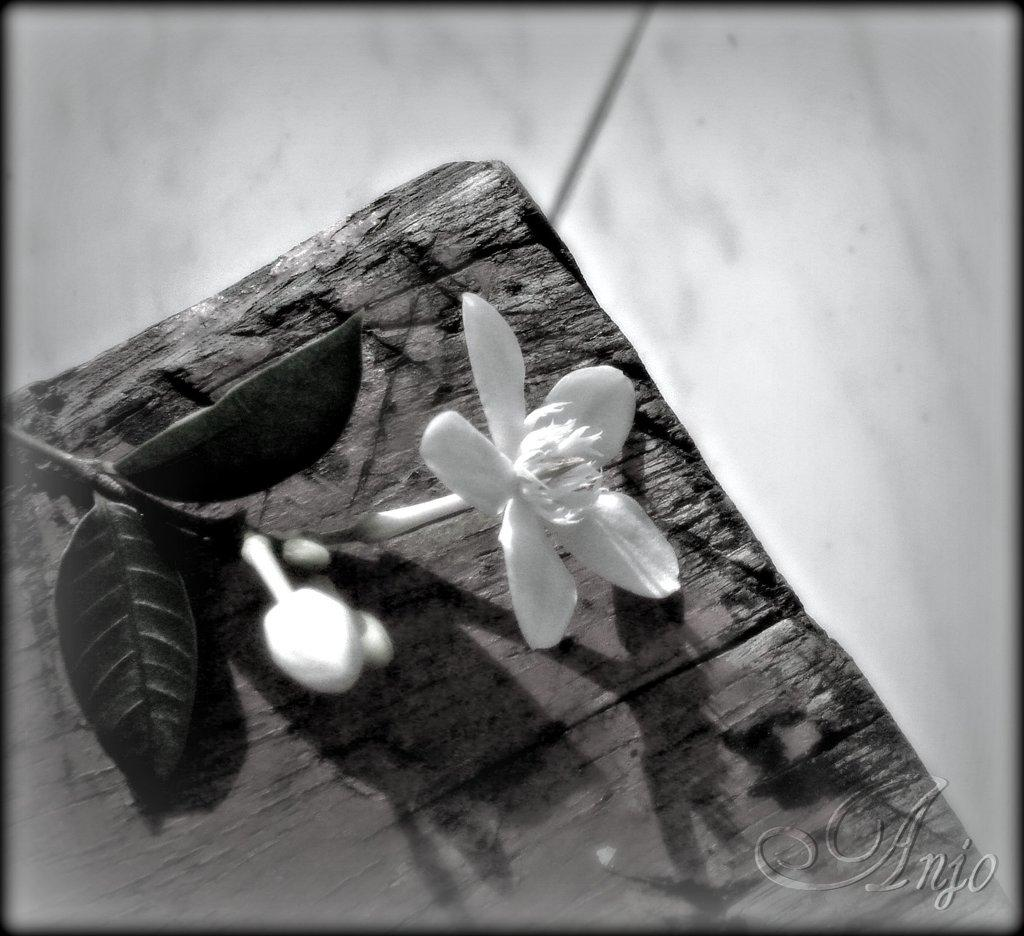What type of image is present in the picture? There is a black and white photograph in the image. What is the subject of the photograph? The photograph depicts a small white flower. Where is the photograph located? The photograph is placed on a wooden rafter. Can you describe the background of the image? The background of the image is blurred. How many wings can be seen on the chickens in the image? There are no chickens present in the image; it features a black and white photograph of a small white flower. 